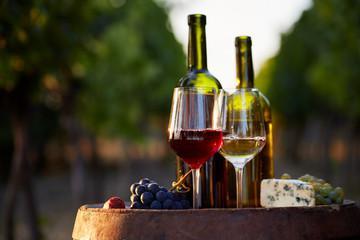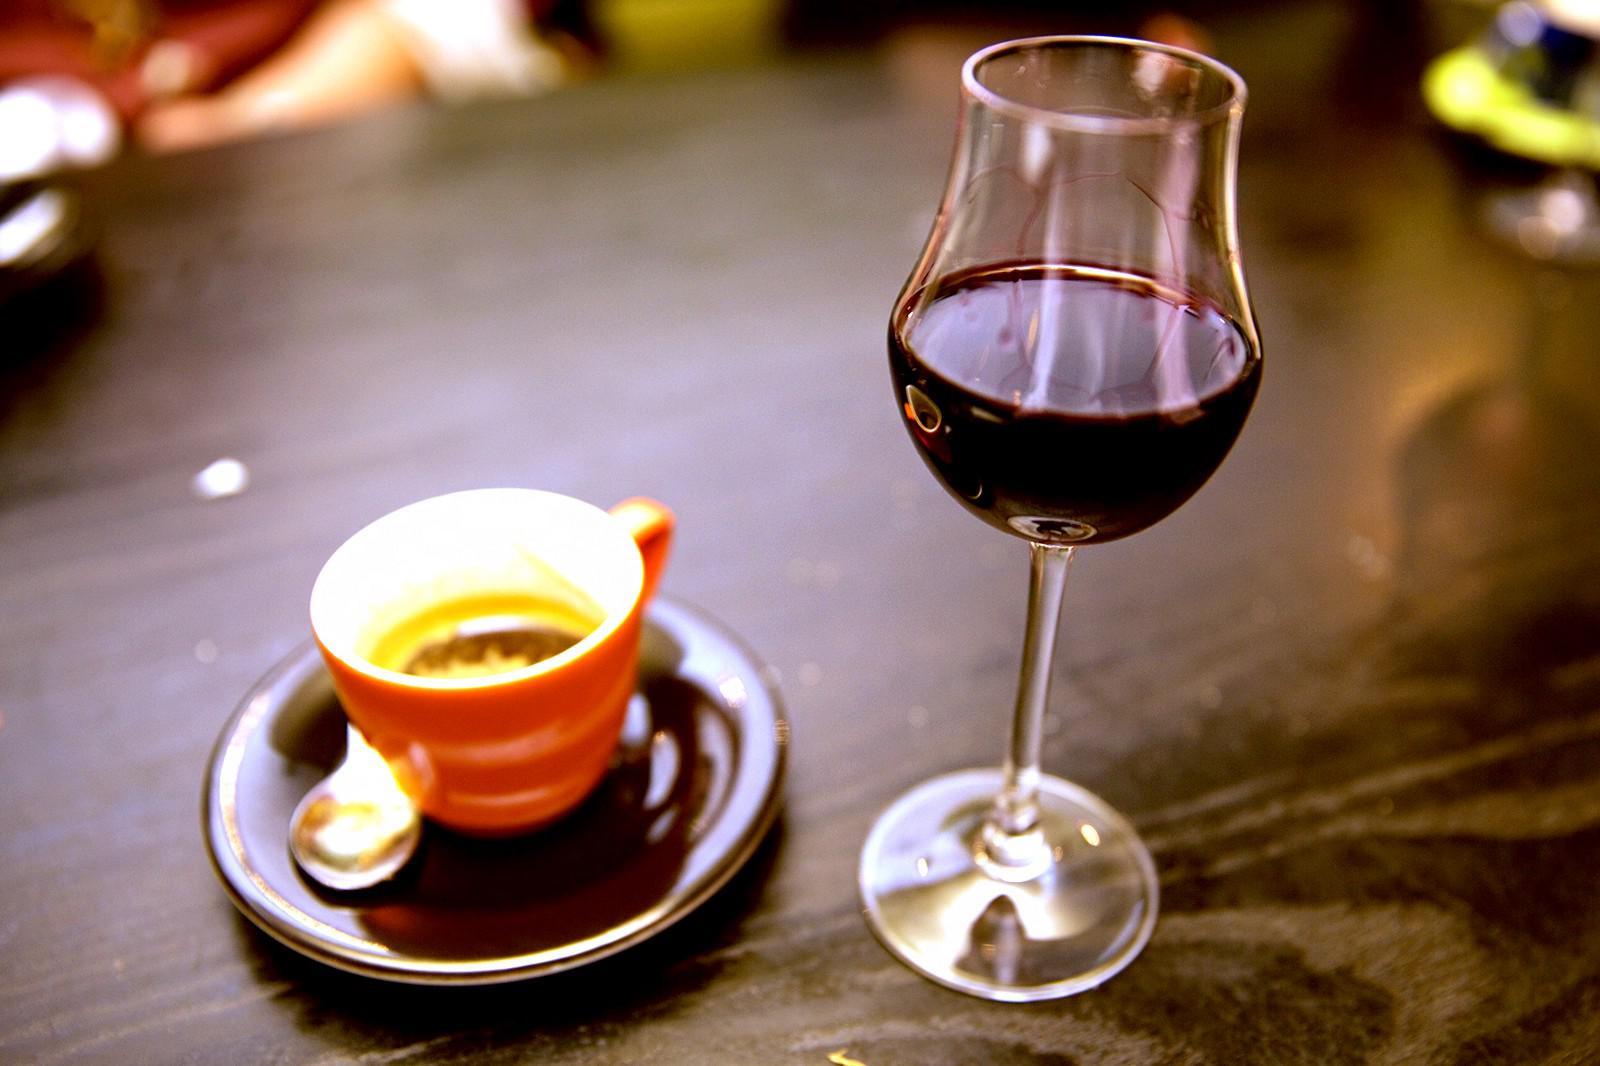The first image is the image on the left, the second image is the image on the right. For the images shown, is this caption "At least one image shows a bunch of grapes near a glass partly filled with red wine." true? Answer yes or no. Yes. The first image is the image on the left, the second image is the image on the right. Evaluate the accuracy of this statement regarding the images: "In one of the images there are two wine glasses next to at least one bottle of wine and a bunch of grapes.". Is it true? Answer yes or no. Yes. 